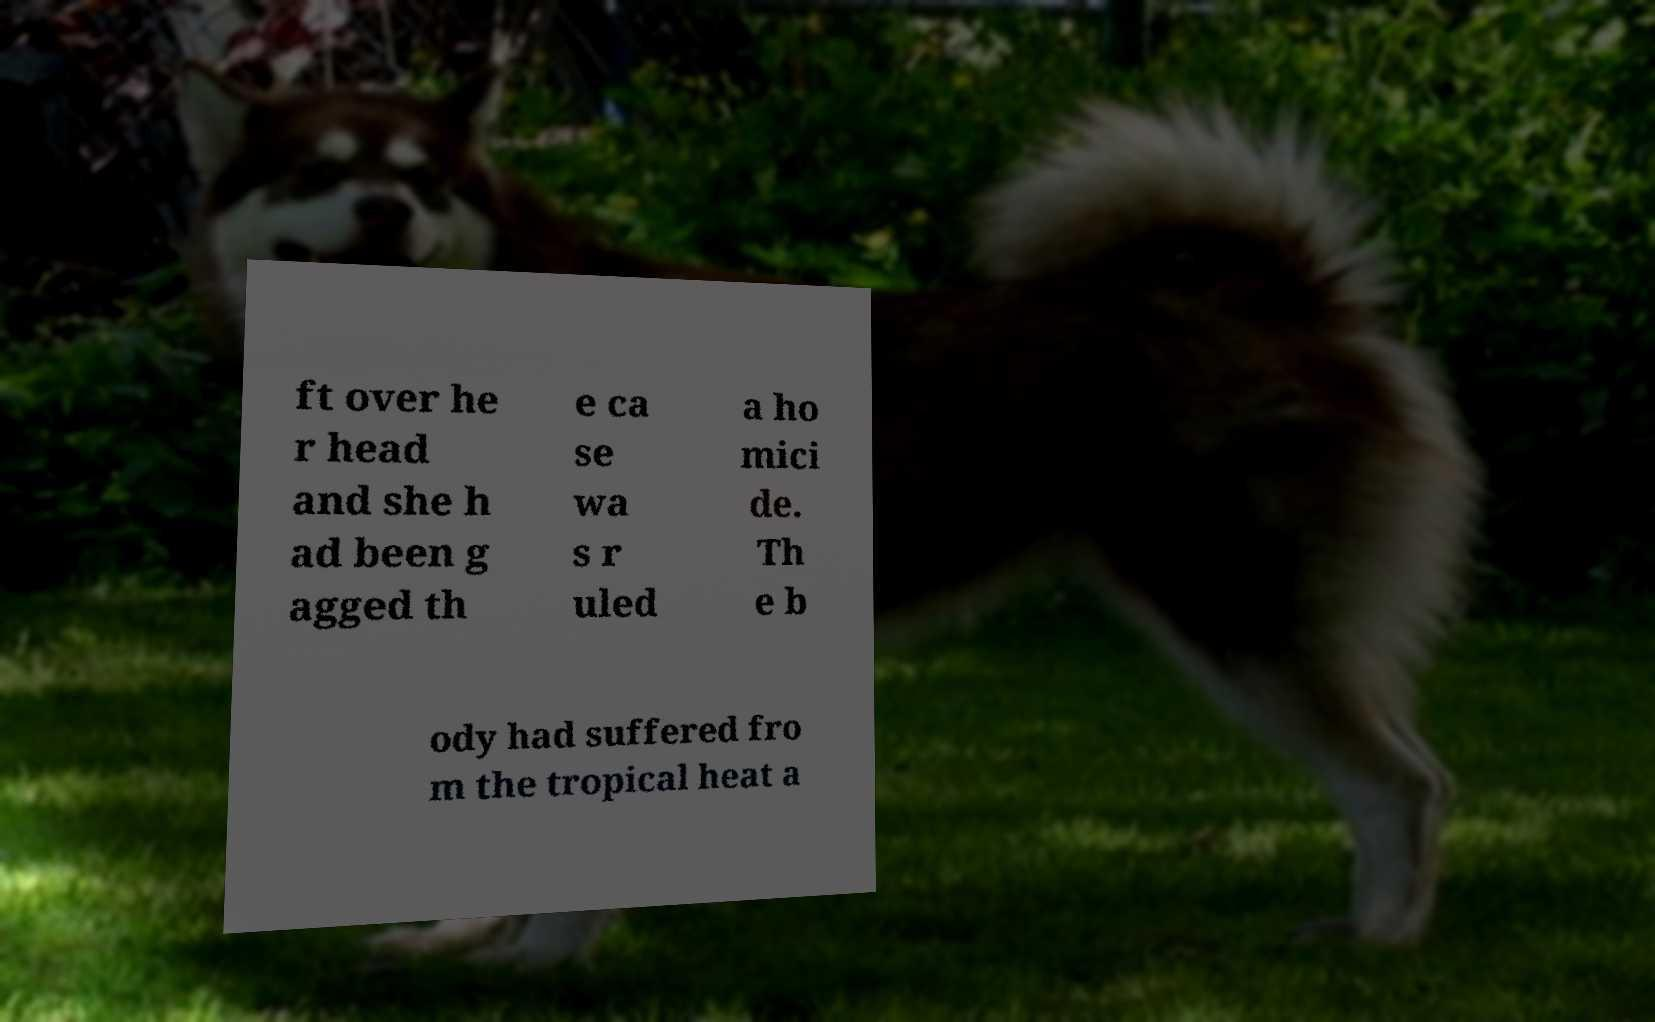Can you accurately transcribe the text from the provided image for me? ft over he r head and she h ad been g agged th e ca se wa s r uled a ho mici de. Th e b ody had suffered fro m the tropical heat a 